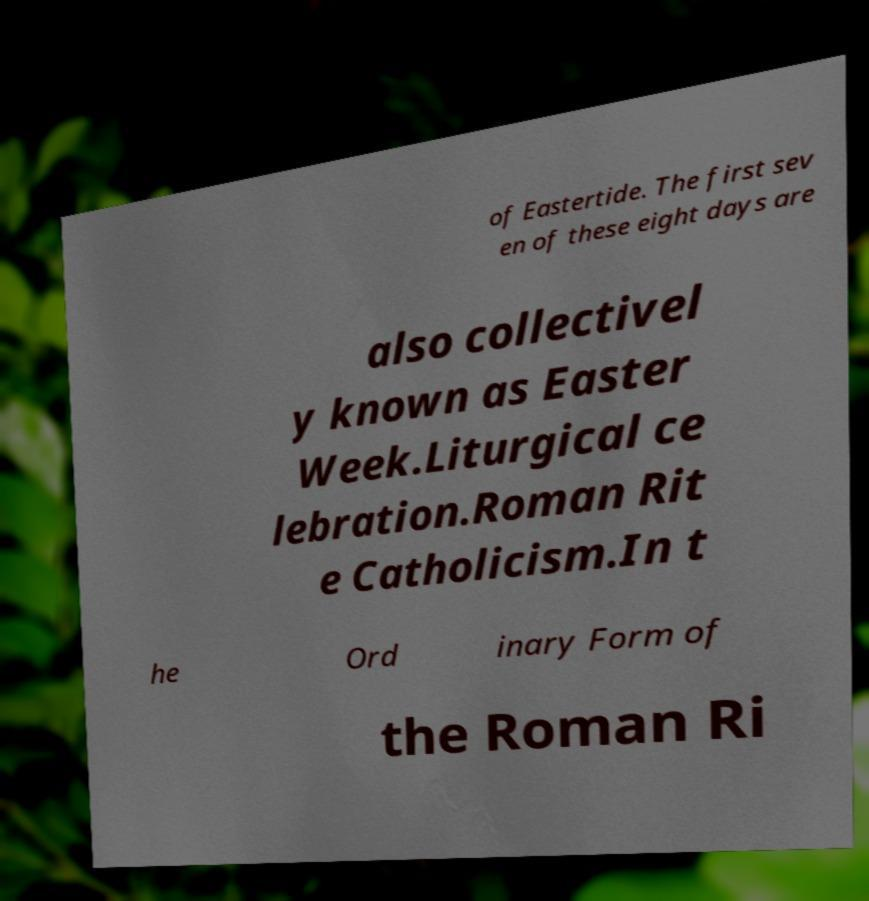For documentation purposes, I need the text within this image transcribed. Could you provide that? of Eastertide. The first sev en of these eight days are also collectivel y known as Easter Week.Liturgical ce lebration.Roman Rit e Catholicism.In t he Ord inary Form of the Roman Ri 